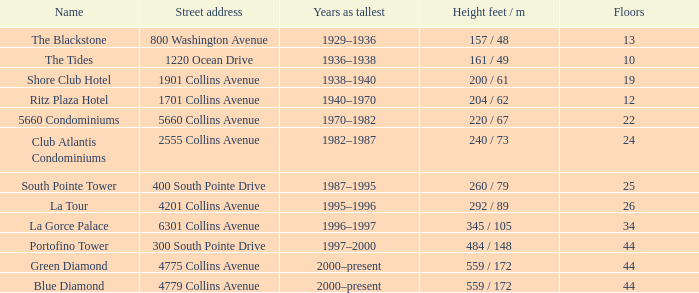Would you be able to parse every entry in this table? {'header': ['Name', 'Street address', 'Years as tallest', 'Height feet / m', 'Floors'], 'rows': [['The Blackstone', '800 Washington Avenue', '1929–1936', '157 / 48', '13'], ['The Tides', '1220 Ocean Drive', '1936–1938', '161 / 49', '10'], ['Shore Club Hotel', '1901 Collins Avenue', '1938–1940', '200 / 61', '19'], ['Ritz Plaza Hotel', '1701 Collins Avenue', '1940–1970', '204 / 62', '12'], ['5660 Condominiums', '5660 Collins Avenue', '1970–1982', '220 / 67', '22'], ['Club Atlantis Condominiums', '2555 Collins Avenue', '1982–1987', '240 / 73', '24'], ['South Pointe Tower', '400 South Pointe Drive', '1987–1995', '260 / 79', '25'], ['La Tour', '4201 Collins Avenue', '1995–1996', '292 / 89', '26'], ['La Gorce Palace', '6301 Collins Avenue', '1996–1997', '345 / 105', '34'], ['Portofino Tower', '300 South Pointe Drive', '1997–2000', '484 / 148', '44'], ['Green Diamond', '4775 Collins Avenue', '2000–present', '559 / 172', '44'], ['Blue Diamond', '4779 Collins Avenue', '2000–present', '559 / 172', '44']]} How many years was the building with 24 floors the tallest? 1982–1987. 